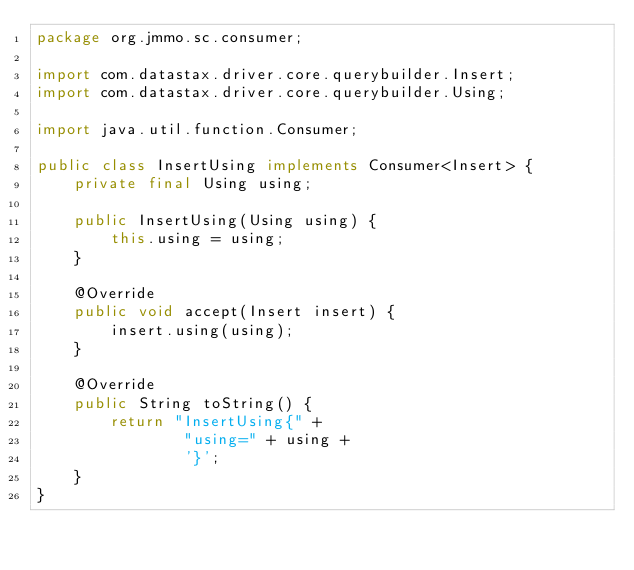<code> <loc_0><loc_0><loc_500><loc_500><_Java_>package org.jmmo.sc.consumer;

import com.datastax.driver.core.querybuilder.Insert;
import com.datastax.driver.core.querybuilder.Using;

import java.util.function.Consumer;

public class InsertUsing implements Consumer<Insert> {
    private final Using using;

    public InsertUsing(Using using) {
        this.using = using;
    }

    @Override
    public void accept(Insert insert) {
        insert.using(using);
    }

    @Override
    public String toString() {
        return "InsertUsing{" +
                "using=" + using +
                '}';
    }
}
</code> 